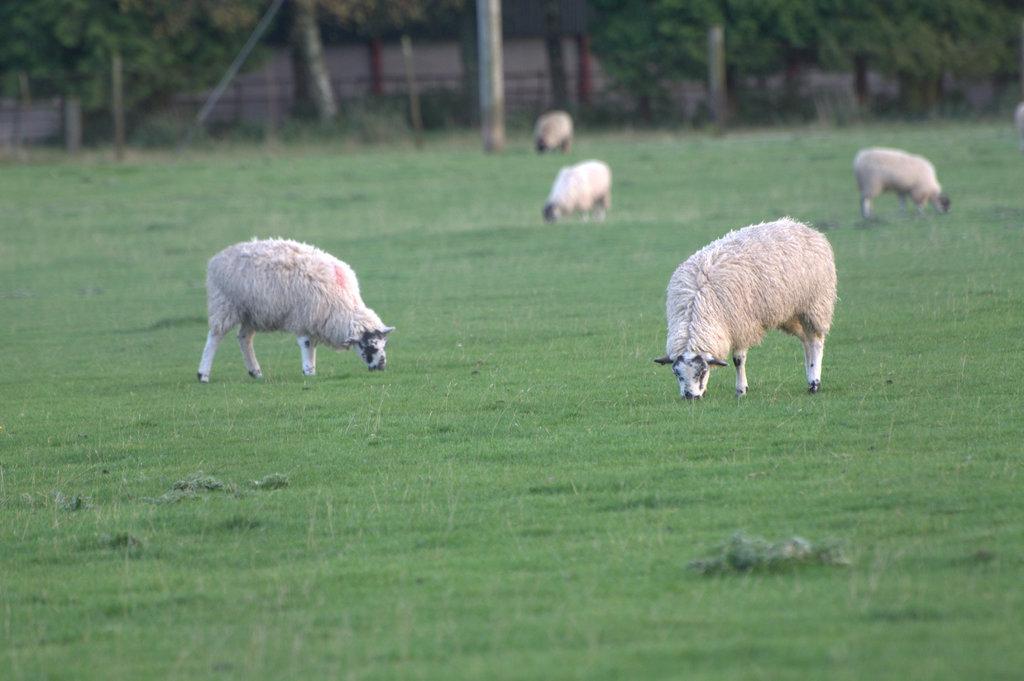Please provide a concise description of this image. In this picture we can see five sheep are grazing, at the bottom there is grass, in the background we can see some trees. 